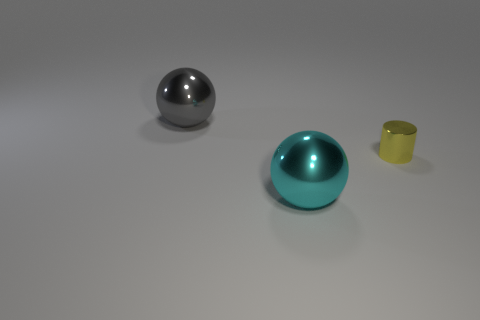Add 3 red shiny cylinders. How many objects exist? 6 Subtract all spheres. How many objects are left? 1 Add 2 large yellow rubber things. How many large yellow rubber things exist? 2 Subtract 1 cyan balls. How many objects are left? 2 Subtract all tiny metallic cylinders. Subtract all brown shiny cubes. How many objects are left? 2 Add 2 tiny yellow metal cylinders. How many tiny yellow metal cylinders are left? 3 